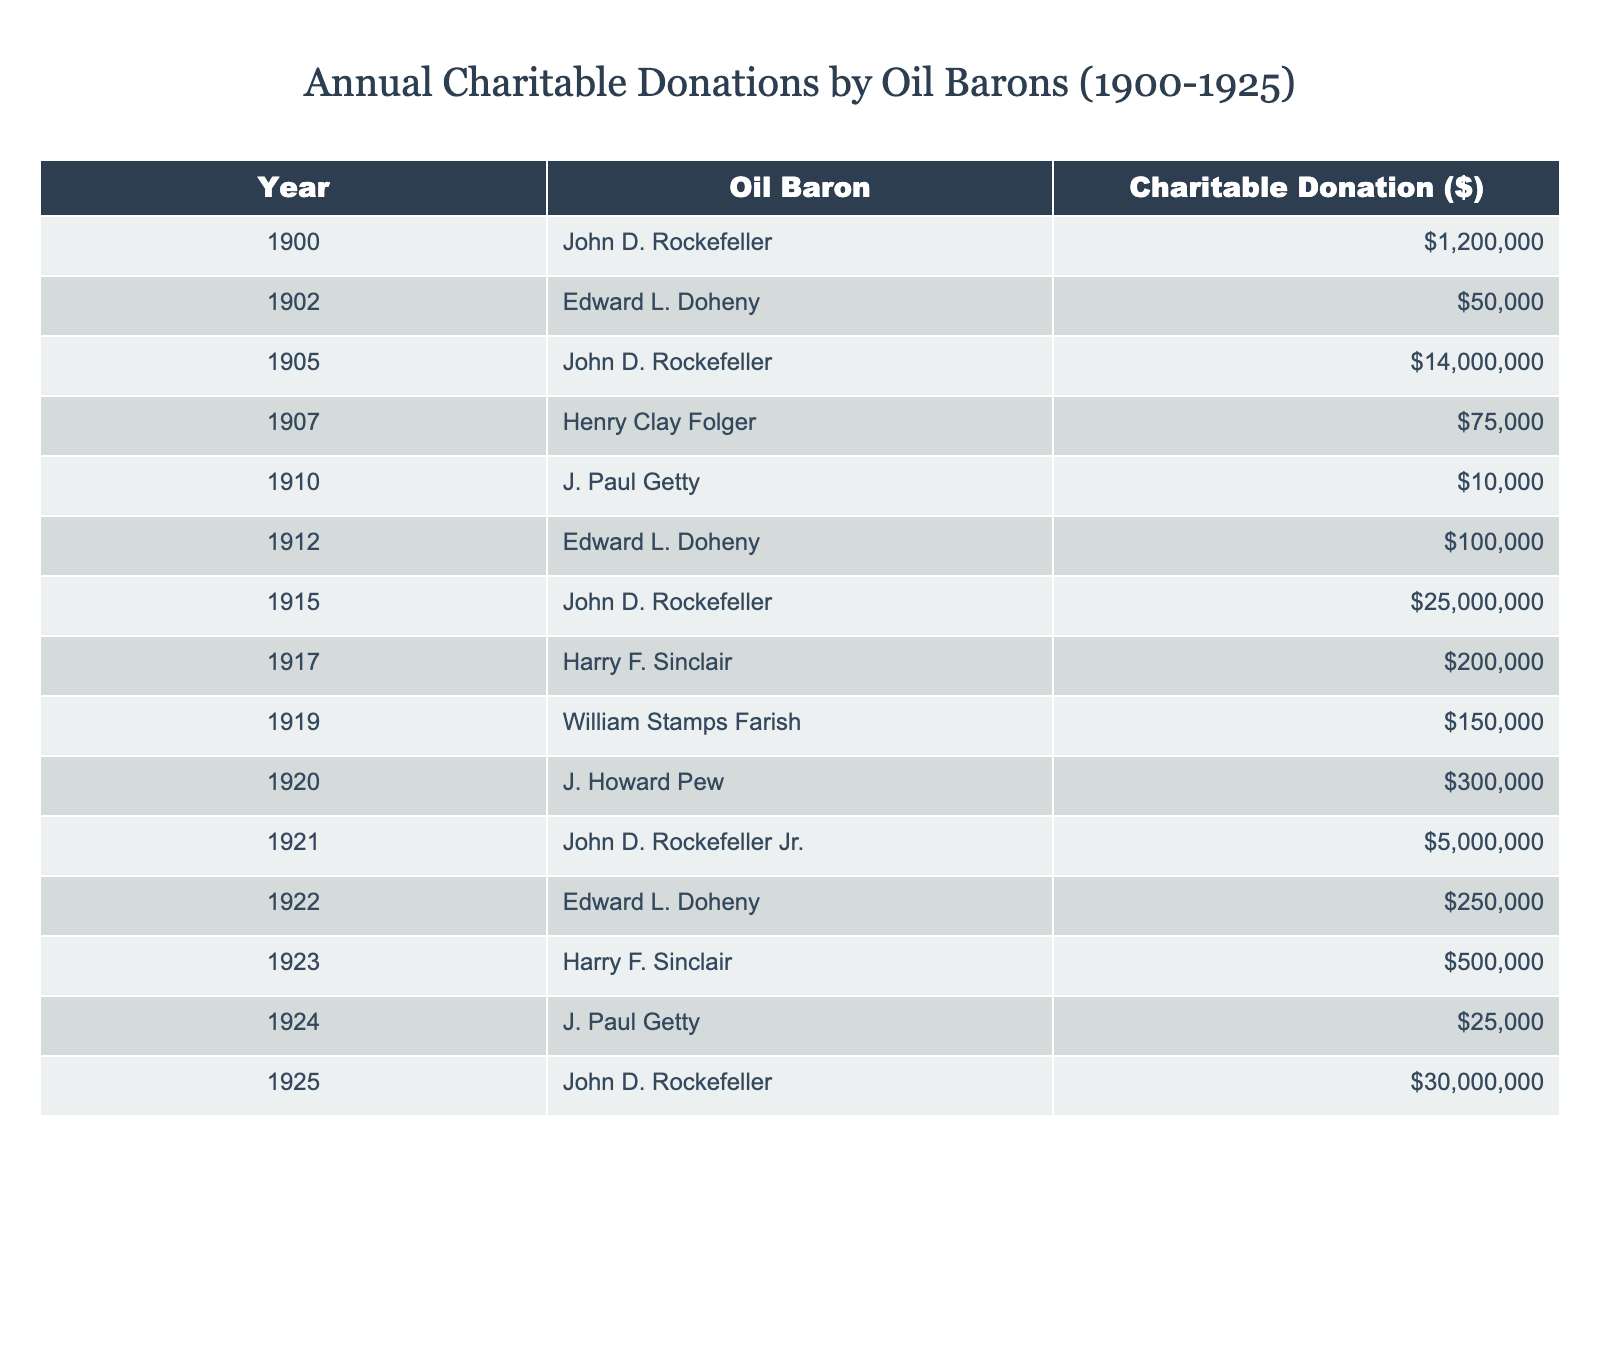What was the highest annual charitable donation made by an oil baron in 1905? In 1905, the table shows that John D. Rockefeller made the highest donation of $14,000,000.
Answer: $14,000,000 Who made a donation of $50,000 in 1902? The table indicates that Edward L. Doheny made a donation of $50,000 in 1902.
Answer: Edward L. Doheny What is the total amount donated by John D. Rockefeller from 1900 to 1925? Adding his donations: $1,200,000 (1900) + $14,000,000 (1905) + $25,000,000 (1915) + $5,000,000 (1921) + $30,000,000 (1925) gives a total of $75,200,000.
Answer: $75,200,000 Did J. Paul Getty donate more in 1920 than in 1924? From the table, J. Paul Getty donated $10,000 in 1910 and $25,000 in 1924, so he did not donate more in 1924 than in 1920 ($10,000).
Answer: No What year saw the most significant increase in charitable donations among oil barons? Analyzing the data, the largest increase is from John D. Rockefeller between 1915 ($25,000,000) and 1925 ($30,000,000), showing a $5,000,000 increase.
Answer: 1915 to 1925 How does Edward L. Doheny's total contribution compare to William Stamps Farish's total contribution? Edward L. Doheny donated $50,000 (1902) + $100,000 (1912) + $250,000 (1922) for a total of $400,000, while William Stamps Farish contributed $150,000 (1919), so Doheny's total ($400,000) is greater than Farish's.
Answer: Doheny's total is greater What percentage of the total donations from 1900 to 1925 were made by John D. Rockefeller? The total donations from all oil barons amount to $75,850,000; John D. Rockefeller's donations total $75,200,000. To find the percentage, we calculate ($75,200,000 / $75,850,000) * 100, resulting in approximately 99%.
Answer: ~99% Which oil baron made charitable donations every year from 1900 to 1925? Inspecting the table confirms that John D. Rockefeller made donations in 1900, 1905, 1915, 1921, and 1925. However, he did not donate every year, so no baron fits this criterion.
Answer: No baron made donations every year 